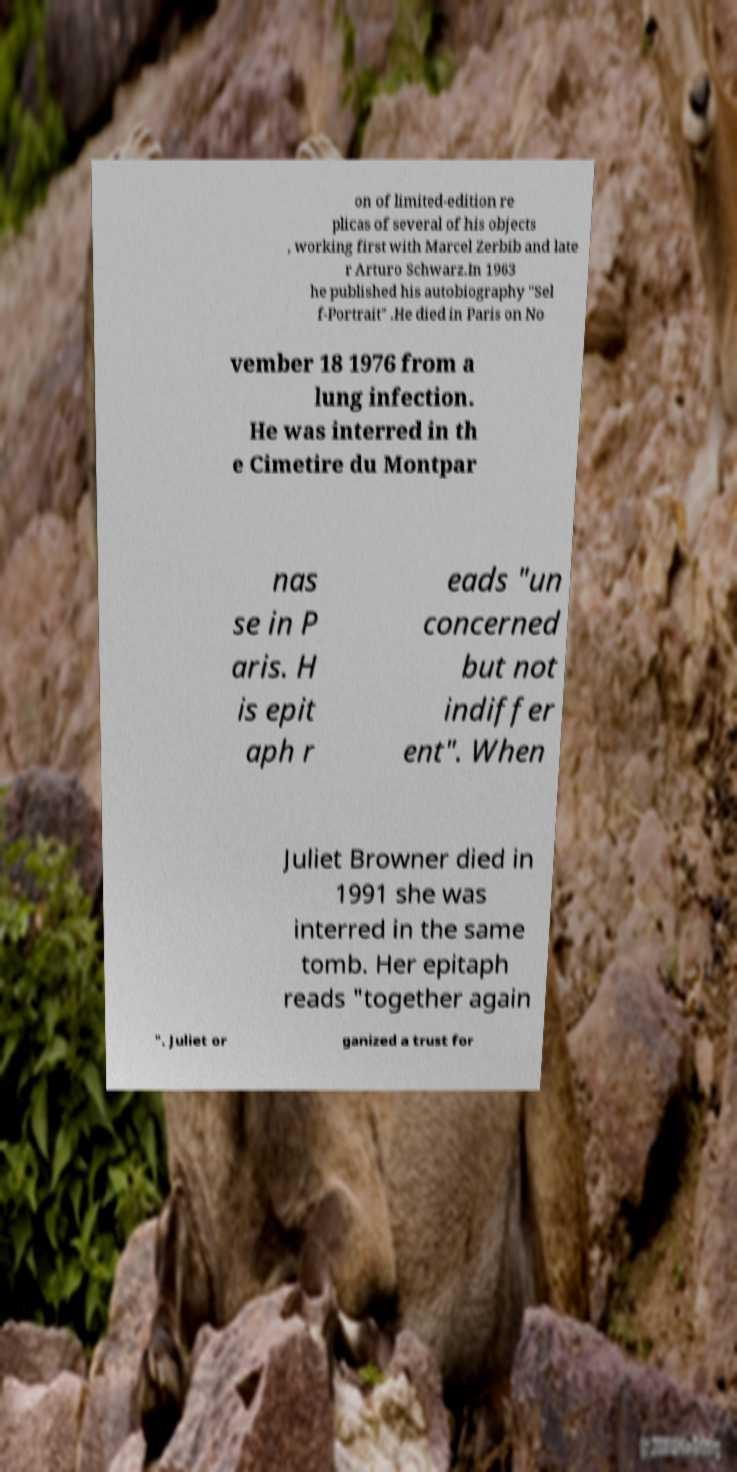Could you extract and type out the text from this image? on of limited-edition re plicas of several of his objects , working first with Marcel Zerbib and late r Arturo Schwarz.In 1963 he published his autobiography "Sel f-Portrait" .He died in Paris on No vember 18 1976 from a lung infection. He was interred in th e Cimetire du Montpar nas se in P aris. H is epit aph r eads "un concerned but not indiffer ent". When Juliet Browner died in 1991 she was interred in the same tomb. Her epitaph reads "together again ". Juliet or ganized a trust for 